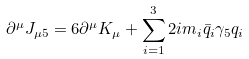Convert formula to latex. <formula><loc_0><loc_0><loc_500><loc_500>\partial ^ { \mu } J _ { \mu 5 } = 6 \partial ^ { \mu } K _ { \mu } + \sum _ { i = 1 } ^ { 3 } 2 i m _ { i } \bar { q } _ { i } \gamma _ { 5 } q _ { i }</formula> 